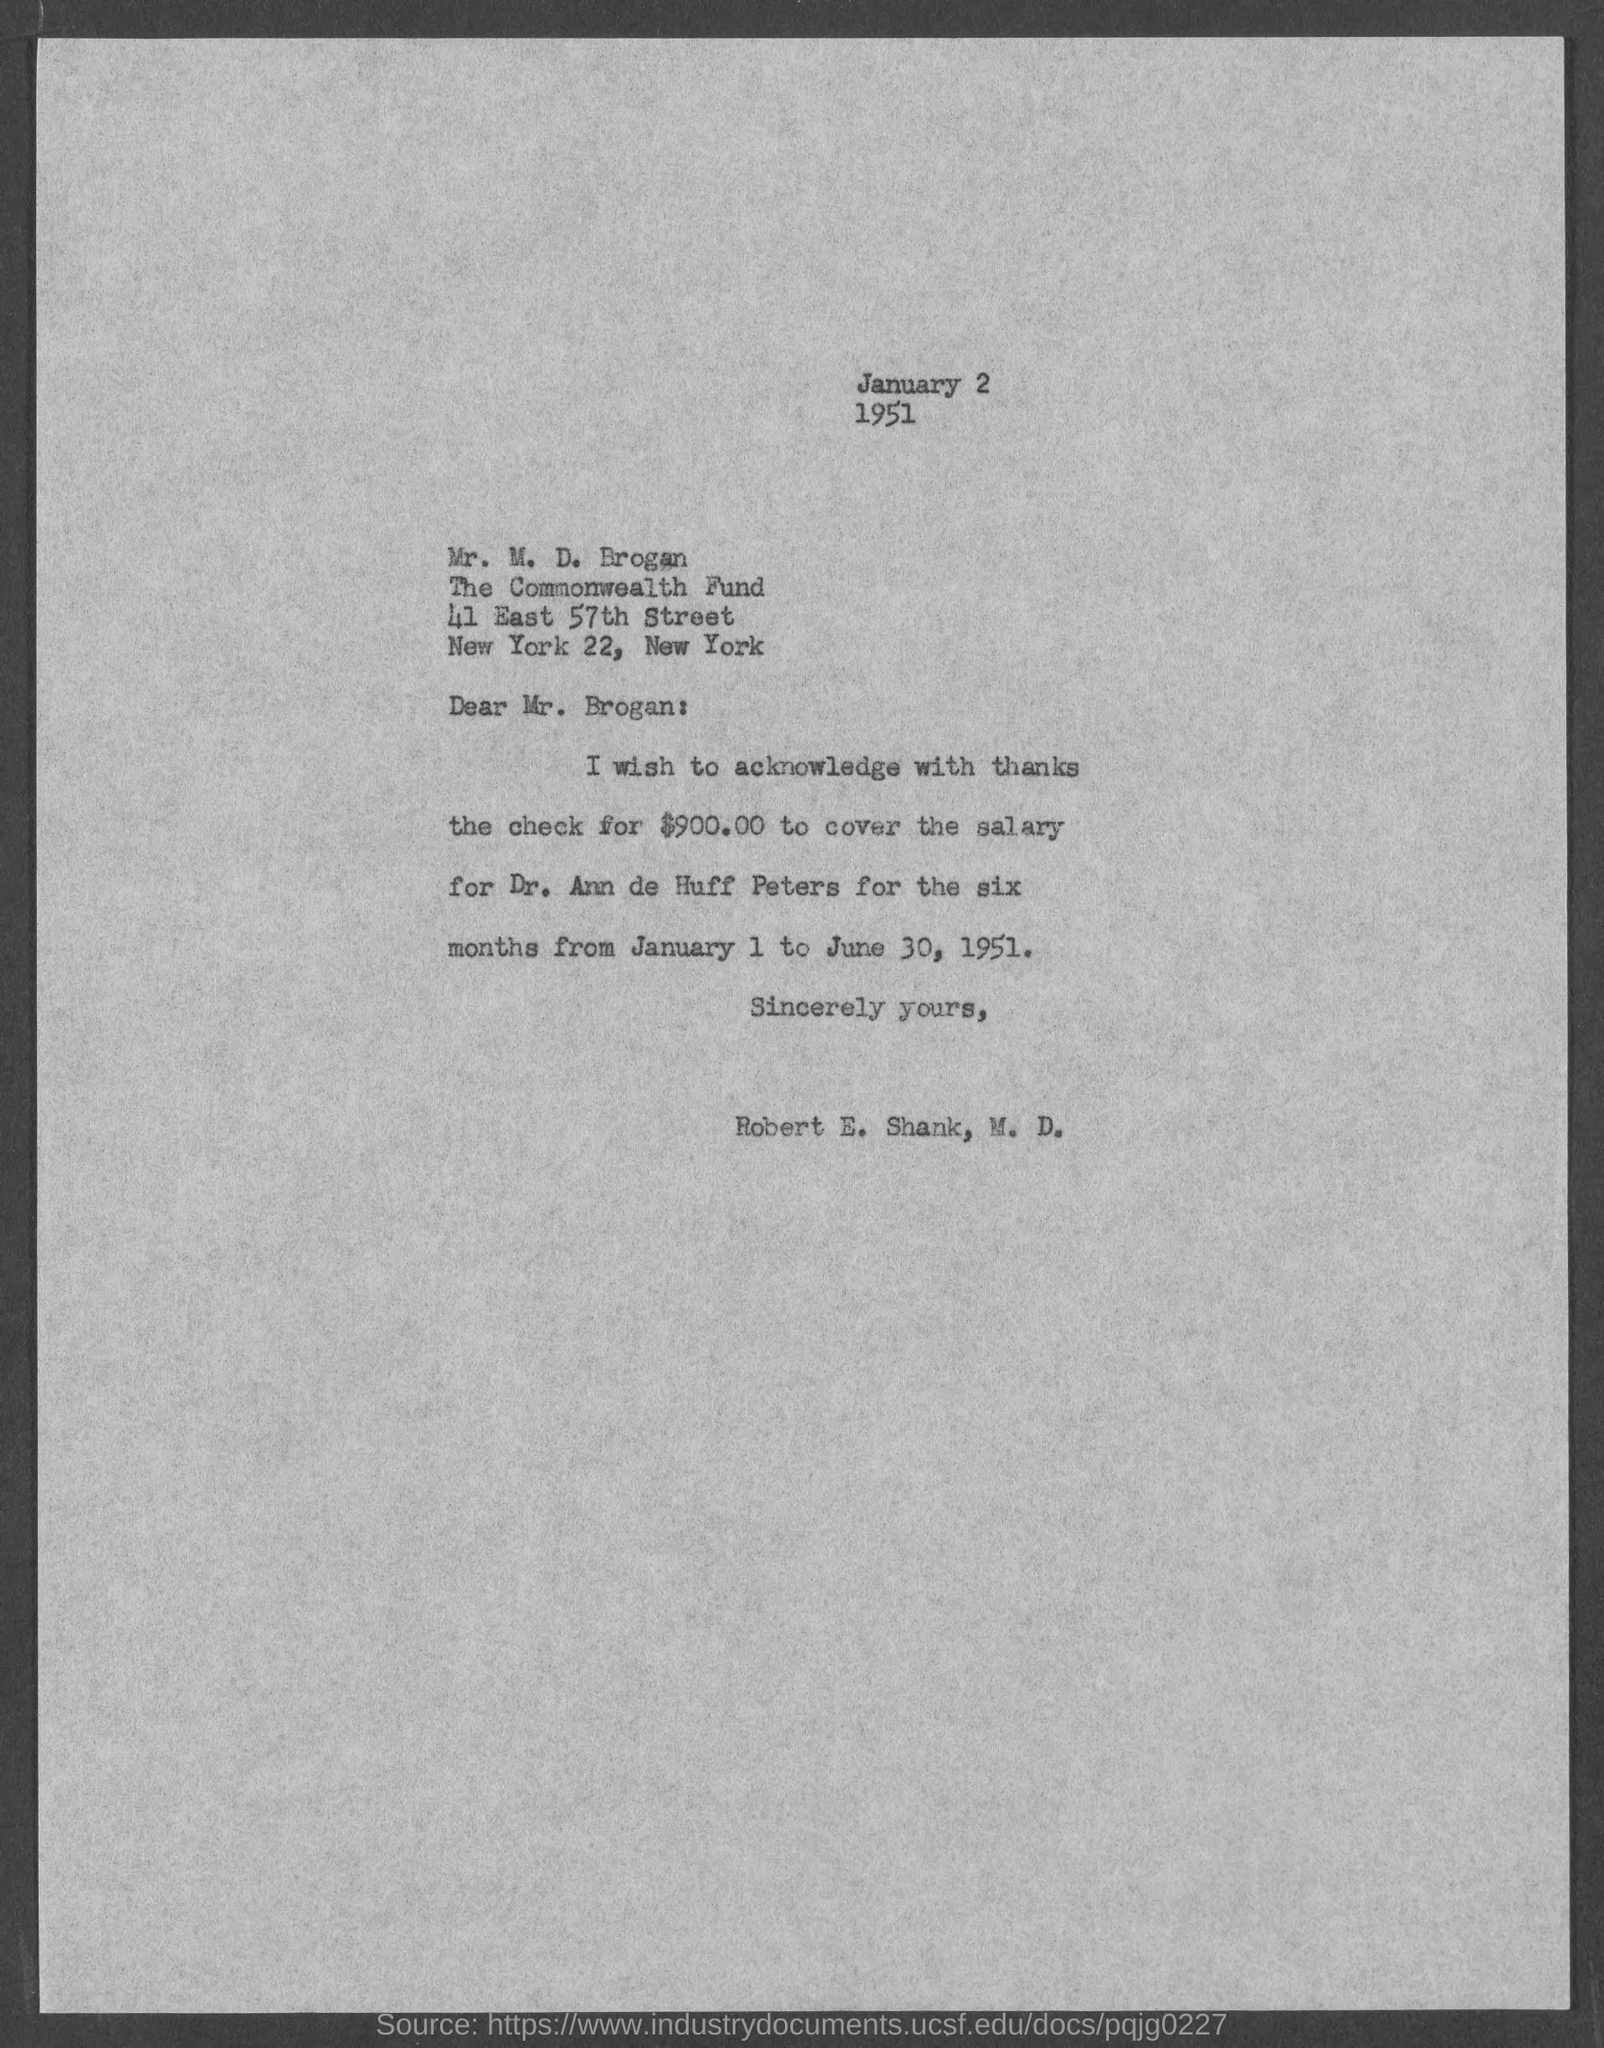List a handful of essential elements in this visual. The check amount mentioned in the letter is $900.00. The salary check is acknowledged in this letter to be Dr. Ann de Huff Peters'. The issued date of this letter is January 2, 1951, as stated in the text. 